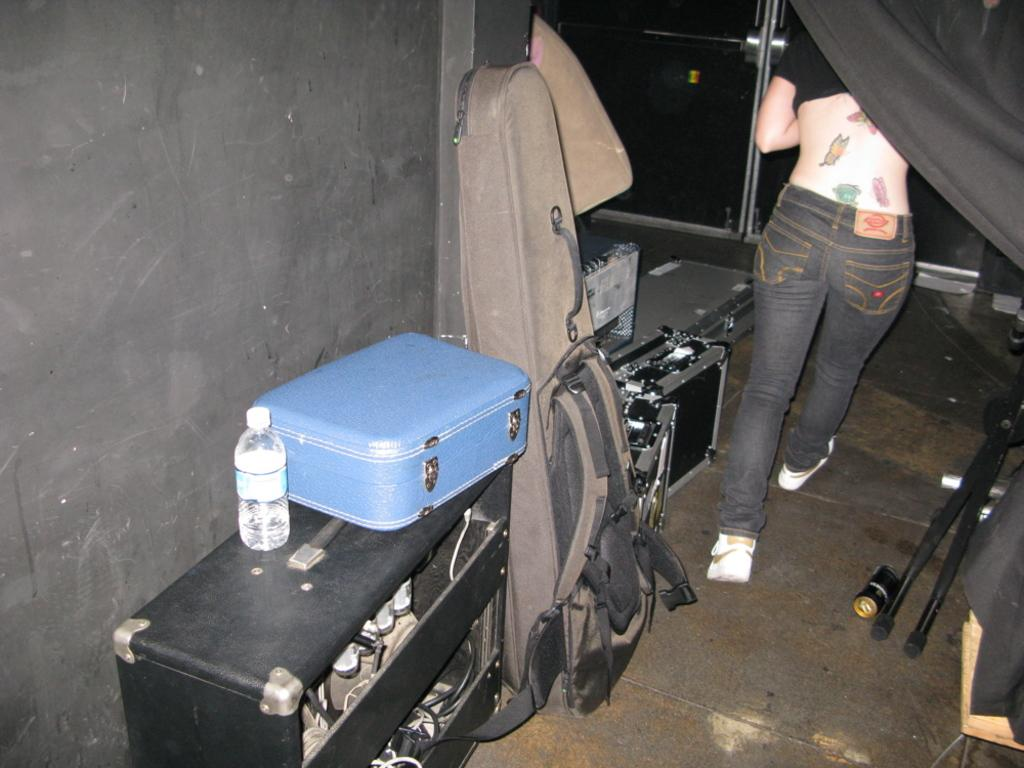What type of luggage is visible in the image? There is a blue suitcase in the image. What else can be seen besides the suitcase? There is a bottle, boxes, and a guitar bag in the image. Can you describe the guitar bag? It is a bag designed to carry a guitar. Is there anything in the background of the image? Yes, there is a person with tattoos on their back in the background. Are there any ants crawling on the blue suitcase in the image? There is no mention of ants in the image, so we cannot determine if any are present. What type of animals can be seen at the zoo in the image? There is no zoo present in the image, so we cannot determine what animals might be there. 